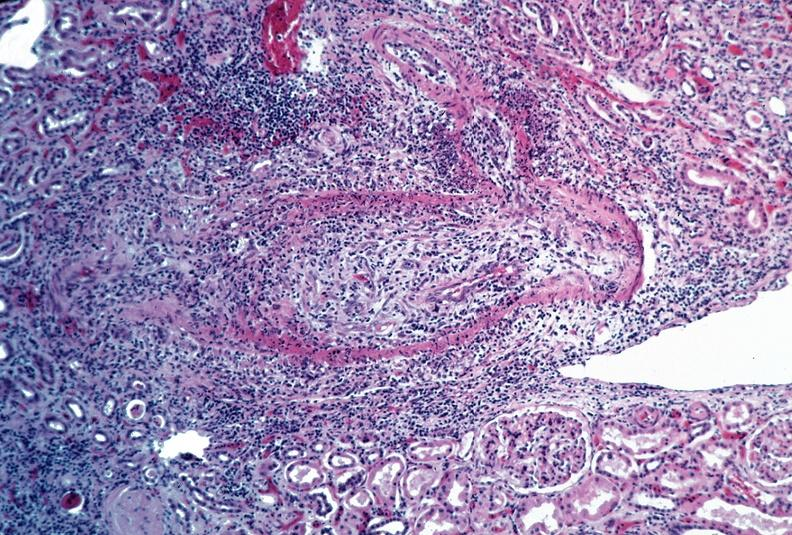s intraductal papillomatosis with apocrine metaplasia present?
Answer the question using a single word or phrase. No 